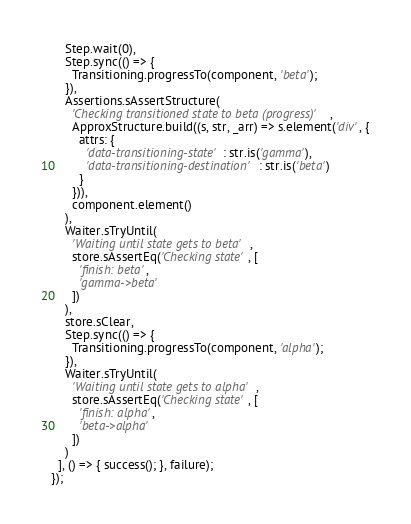Convert code to text. <code><loc_0><loc_0><loc_500><loc_500><_TypeScript_>    Step.wait(0),
    Step.sync(() => {
      Transitioning.progressTo(component, 'beta');
    }),
    Assertions.sAssertStructure(
      'Checking transitioned state to beta (progress)',
      ApproxStructure.build((s, str, _arr) => s.element('div', {
        attrs: {
          'data-transitioning-state': str.is('gamma'),
          'data-transitioning-destination': str.is('beta')
        }
      })),
      component.element()
    ),
    Waiter.sTryUntil(
      'Waiting until state gets to beta',
      store.sAssertEq('Checking state', [
        'finish: beta',
        'gamma->beta'
      ])
    ),
    store.sClear,
    Step.sync(() => {
      Transitioning.progressTo(component, 'alpha');
    }),
    Waiter.sTryUntil(
      'Waiting until state gets to alpha',
      store.sAssertEq('Checking state', [
        'finish: alpha',
        'beta->alpha'
      ])
    )
  ], () => { success(); }, failure);
});
</code> 